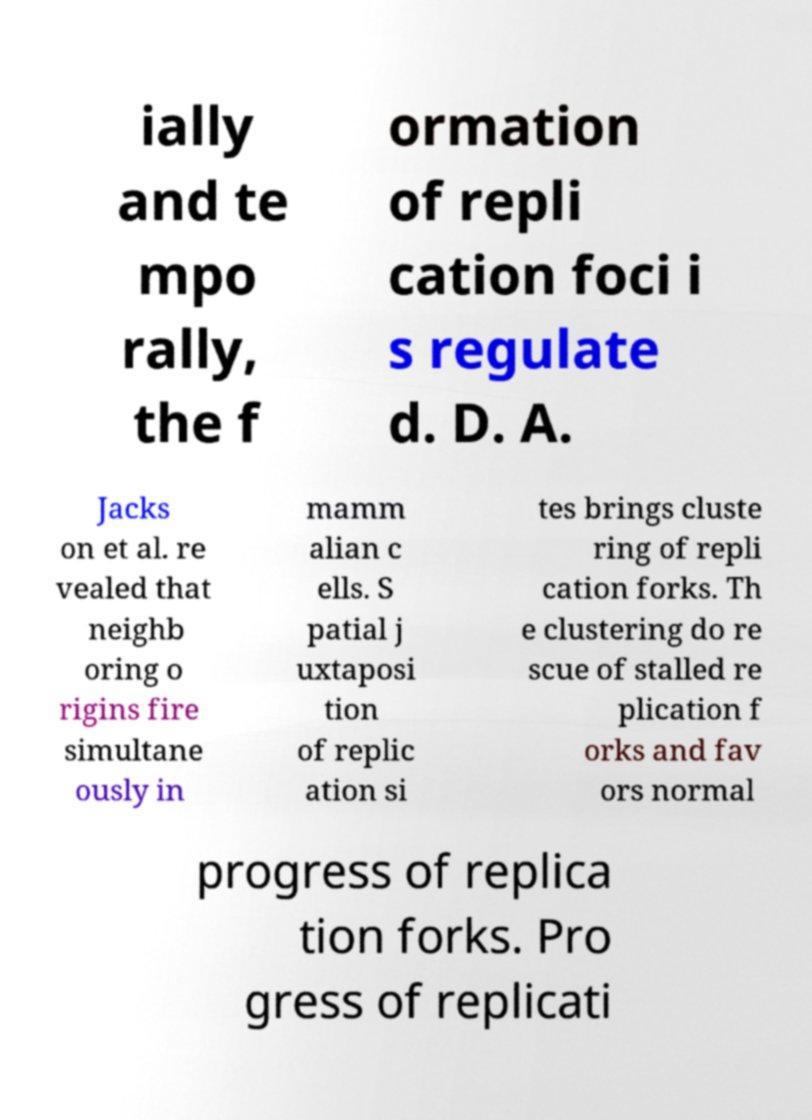Please read and relay the text visible in this image. What does it say? ially and te mpo rally, the f ormation of repli cation foci i s regulate d. D. A. Jacks on et al. re vealed that neighb oring o rigins fire simultane ously in mamm alian c ells. S patial j uxtaposi tion of replic ation si tes brings cluste ring of repli cation forks. Th e clustering do re scue of stalled re plication f orks and fav ors normal progress of replica tion forks. Pro gress of replicati 